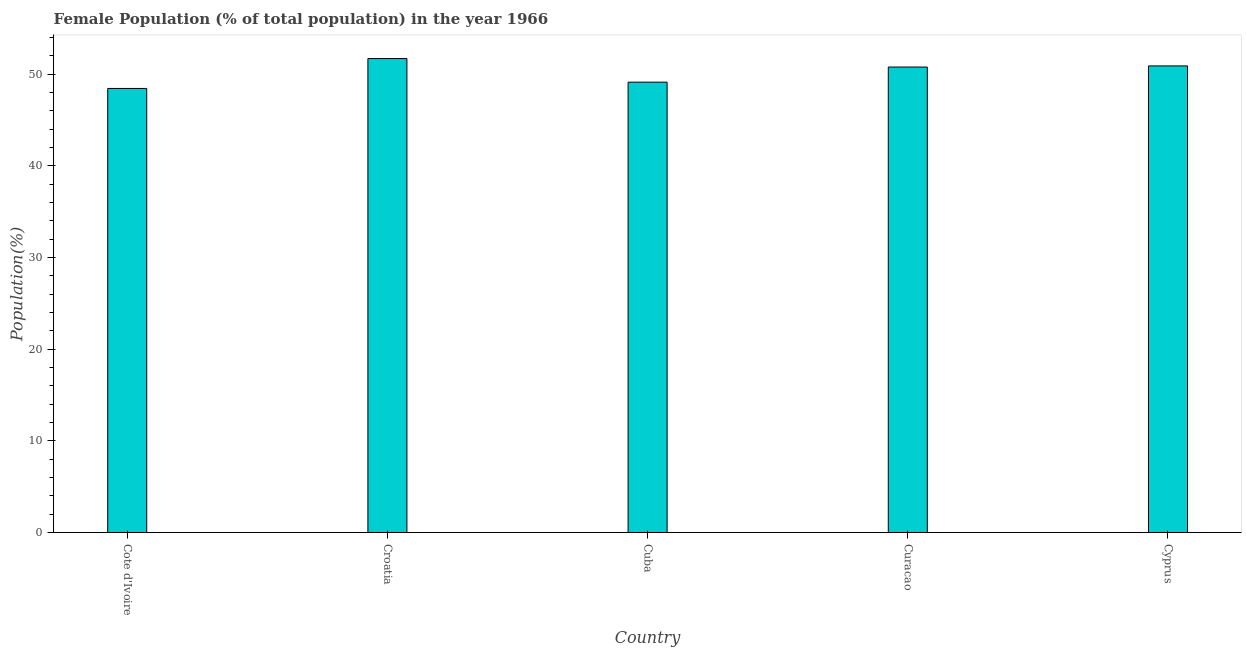Does the graph contain grids?
Make the answer very short. No. What is the title of the graph?
Your answer should be very brief. Female Population (% of total population) in the year 1966. What is the label or title of the X-axis?
Give a very brief answer. Country. What is the label or title of the Y-axis?
Ensure brevity in your answer.  Population(%). What is the female population in Curacao?
Offer a very short reply. 50.77. Across all countries, what is the maximum female population?
Provide a short and direct response. 51.69. Across all countries, what is the minimum female population?
Provide a short and direct response. 48.43. In which country was the female population maximum?
Offer a terse response. Croatia. In which country was the female population minimum?
Make the answer very short. Cote d'Ivoire. What is the sum of the female population?
Give a very brief answer. 250.9. What is the difference between the female population in Cote d'Ivoire and Cyprus?
Provide a short and direct response. -2.46. What is the average female population per country?
Offer a very short reply. 50.18. What is the median female population?
Offer a very short reply. 50.77. In how many countries, is the female population greater than 2 %?
Give a very brief answer. 5. What is the ratio of the female population in Cuba to that in Curacao?
Offer a terse response. 0.97. What is the difference between the highest and the lowest female population?
Make the answer very short. 3.26. In how many countries, is the female population greater than the average female population taken over all countries?
Your response must be concise. 3. How many bars are there?
Keep it short and to the point. 5. Are all the bars in the graph horizontal?
Offer a very short reply. No. How many countries are there in the graph?
Your response must be concise. 5. Are the values on the major ticks of Y-axis written in scientific E-notation?
Offer a terse response. No. What is the Population(%) in Cote d'Ivoire?
Provide a short and direct response. 48.43. What is the Population(%) of Croatia?
Give a very brief answer. 51.69. What is the Population(%) of Cuba?
Make the answer very short. 49.12. What is the Population(%) of Curacao?
Your answer should be very brief. 50.77. What is the Population(%) of Cyprus?
Your answer should be very brief. 50.89. What is the difference between the Population(%) in Cote d'Ivoire and Croatia?
Offer a terse response. -3.26. What is the difference between the Population(%) in Cote d'Ivoire and Cuba?
Your answer should be very brief. -0.69. What is the difference between the Population(%) in Cote d'Ivoire and Curacao?
Your answer should be compact. -2.33. What is the difference between the Population(%) in Cote d'Ivoire and Cyprus?
Provide a succinct answer. -2.46. What is the difference between the Population(%) in Croatia and Cuba?
Ensure brevity in your answer.  2.57. What is the difference between the Population(%) in Croatia and Curacao?
Keep it short and to the point. 0.92. What is the difference between the Population(%) in Croatia and Cyprus?
Your answer should be very brief. 0.8. What is the difference between the Population(%) in Cuba and Curacao?
Keep it short and to the point. -1.65. What is the difference between the Population(%) in Cuba and Cyprus?
Offer a very short reply. -1.77. What is the difference between the Population(%) in Curacao and Cyprus?
Offer a very short reply. -0.12. What is the ratio of the Population(%) in Cote d'Ivoire to that in Croatia?
Keep it short and to the point. 0.94. What is the ratio of the Population(%) in Cote d'Ivoire to that in Cuba?
Keep it short and to the point. 0.99. What is the ratio of the Population(%) in Cote d'Ivoire to that in Curacao?
Provide a succinct answer. 0.95. What is the ratio of the Population(%) in Cote d'Ivoire to that in Cyprus?
Offer a very short reply. 0.95. What is the ratio of the Population(%) in Croatia to that in Cuba?
Your answer should be compact. 1.05. What is the ratio of the Population(%) in Cuba to that in Curacao?
Keep it short and to the point. 0.97. 